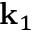<formula> <loc_0><loc_0><loc_500><loc_500>k _ { 1 }</formula> 